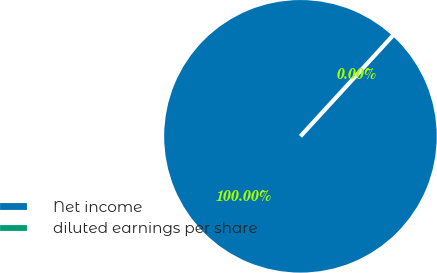<chart> <loc_0><loc_0><loc_500><loc_500><pie_chart><fcel>Net income<fcel>diluted earnings per share<nl><fcel>100.0%<fcel>0.0%<nl></chart> 